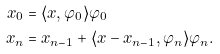Convert formula to latex. <formula><loc_0><loc_0><loc_500><loc_500>x _ { 0 } & = \langle x , \varphi _ { 0 } \rangle \varphi _ { 0 } \\ x _ { n } & = x _ { n - 1 } + \langle x - x _ { n - 1 } , \varphi _ { n } \rangle \varphi _ { n } .</formula> 